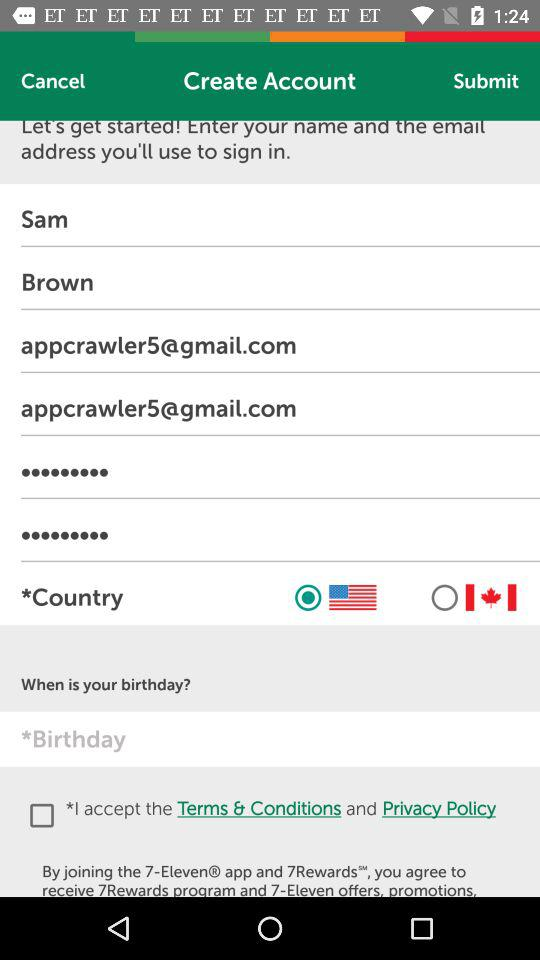What is the first name? The first name is Sam. 